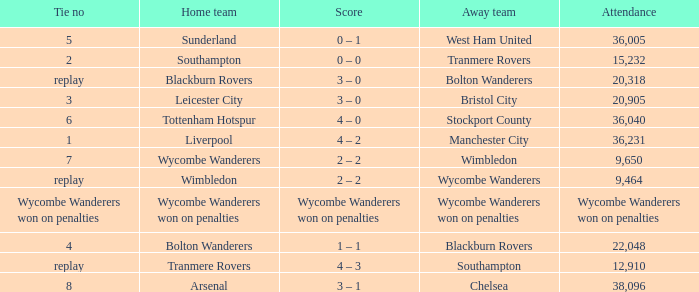What was the score for the game where the home team was Wycombe Wanderers? 2 – 2. 